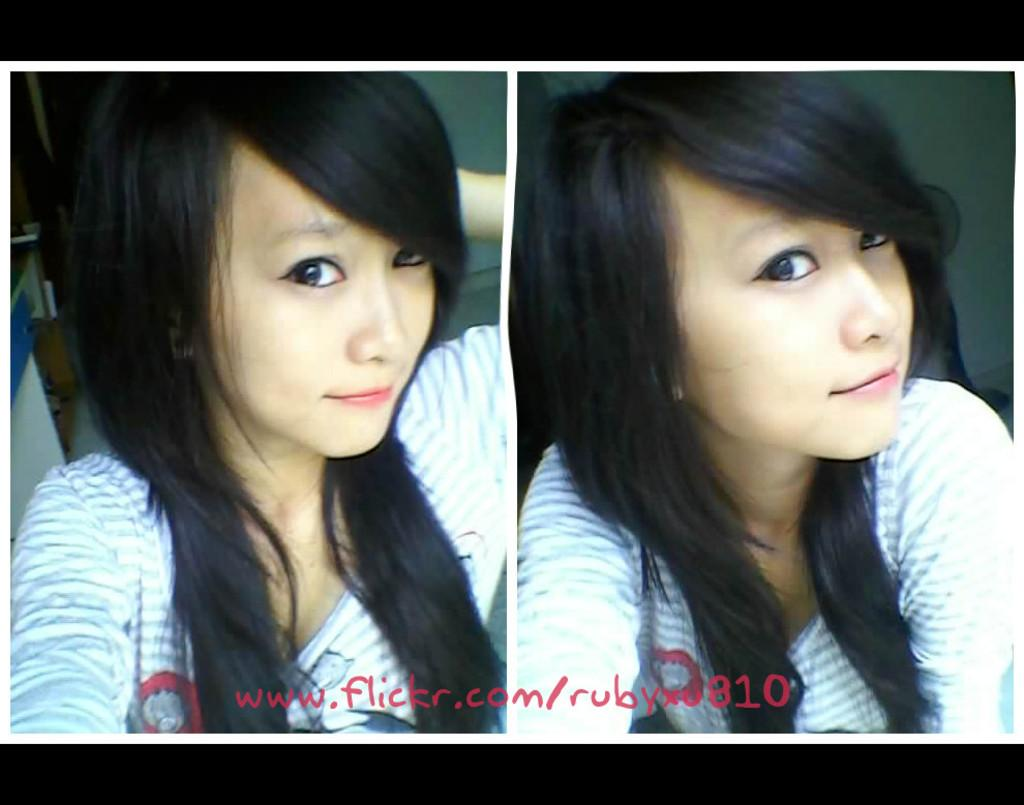What is the composition of the image? The image is a collage of two images. Can you describe the subject of each image? There is a woman in both images. Is there any text present in the image? Yes, there is some text at the bottom of the collage. What type of playground equipment can be seen in the image? There is no playground equipment present in the image; it is a collage of two images featuring a woman. How much dust is visible on the woman in the image? There is no visible dust on the woman in the image, as the image is a collage of two images featuring a woman. 